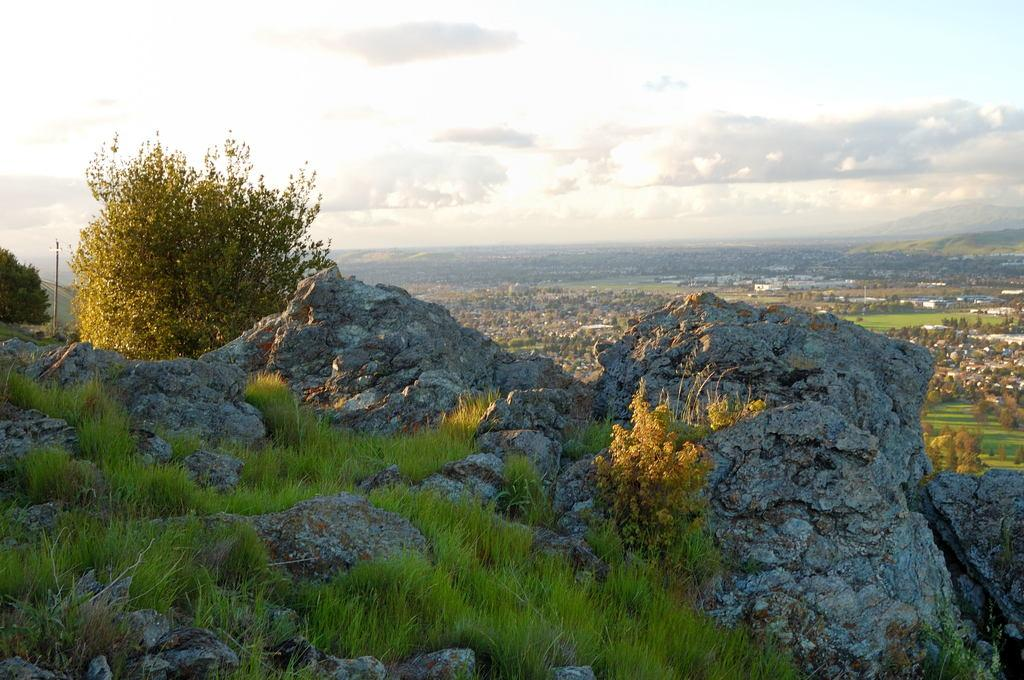What type of vegetation is growing on the rocks in the image? There is grass on the rocks in the image. What other types of vegetation can be seen in the image? There are plants visible in the image. Where is the pole located in the image? The pole is on the left side of the image. What can be seen in the background of the image? There are trees and houses in the background of the image. What is the condition of the sky in the image? The sky is cloudy in the image. What type of cloth is draped over the shelf in the image? There is no shelf or cloth present in the image. Who are the members of the committee in the image? There is no committee present in the image. 